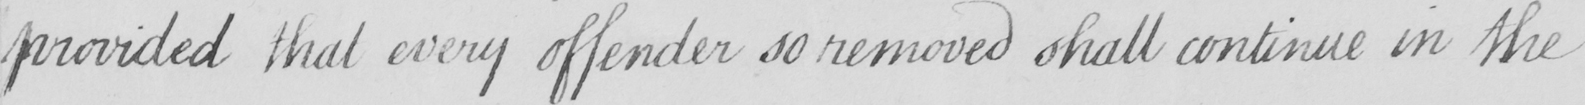Please transcribe the handwritten text in this image. provided that every offender so removed shall continue in the 